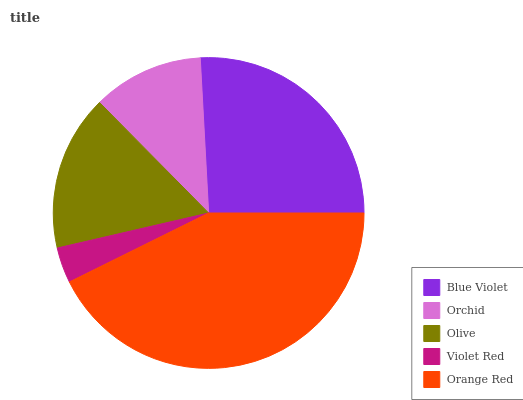Is Violet Red the minimum?
Answer yes or no. Yes. Is Orange Red the maximum?
Answer yes or no. Yes. Is Orchid the minimum?
Answer yes or no. No. Is Orchid the maximum?
Answer yes or no. No. Is Blue Violet greater than Orchid?
Answer yes or no. Yes. Is Orchid less than Blue Violet?
Answer yes or no. Yes. Is Orchid greater than Blue Violet?
Answer yes or no. No. Is Blue Violet less than Orchid?
Answer yes or no. No. Is Olive the high median?
Answer yes or no. Yes. Is Olive the low median?
Answer yes or no. Yes. Is Blue Violet the high median?
Answer yes or no. No. Is Orange Red the low median?
Answer yes or no. No. 